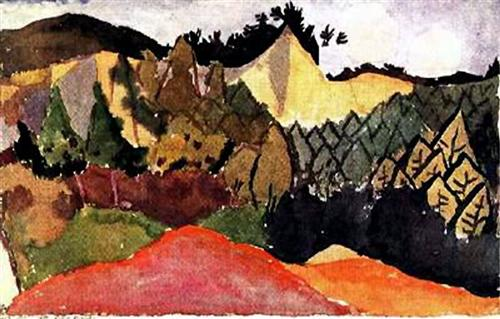Can you describe the main features of this image for me? The image presents a striking landscape painting that features a sweeping view of a mountain range that gradually diminishes into the horizon. In the foreground, a sprawling valley is depicted with vivid colors and expressive brushstrokes. This post-impressionist artwork employs a rich palette dominated by shades of red, yellow, and green, interspersed with touches of black and white for added depth and contrast. The style of the painting, with its bold color choices and loose, dynamic brushwork, suggests it may be influenced by Fauvism, an art movement that emphasizes strong painterly qualities and vibrant, nonrepresentational color over more realistic portrayals. The overall effect is one of lively, expressive energy that invites viewers to explore the visual narrative embedded in the landscape. 